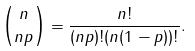Convert formula to latex. <formula><loc_0><loc_0><loc_500><loc_500>\binom { n } { n p } = \frac { n ! } { ( n p ) ! ( n ( 1 - p ) ) ! } .</formula> 